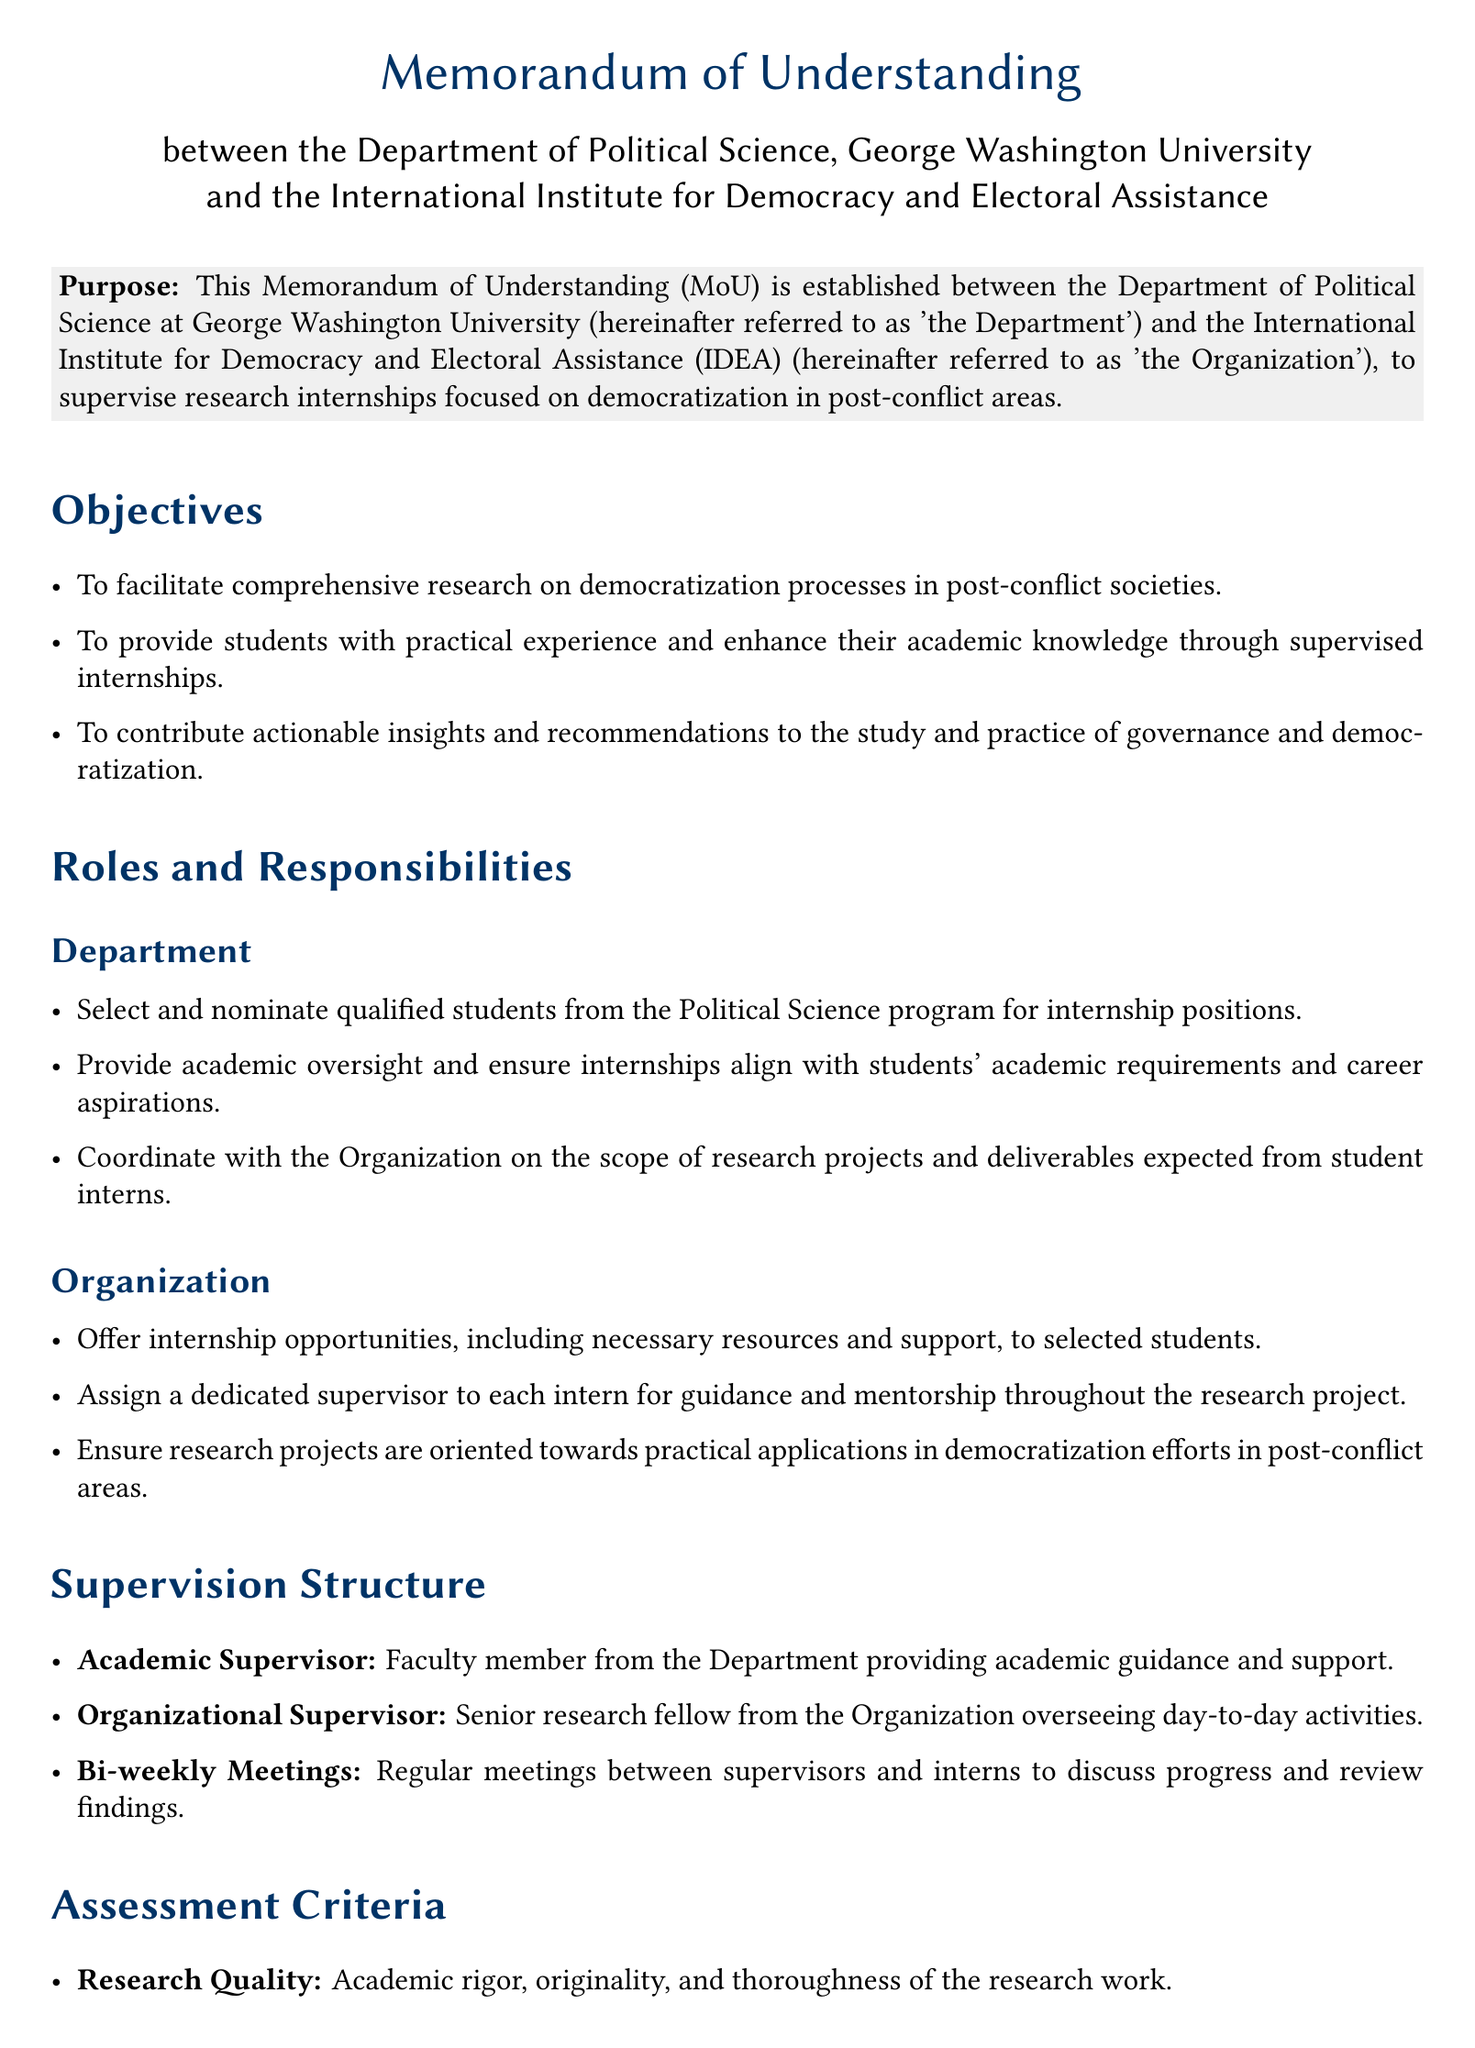What are the names of the two parties involved? The document identifies the two parties as the Department of Political Science at George Washington University and the International Institute for Democracy and Electoral Assistance.
Answer: Department of Political Science, International Institute for Democracy and Electoral Assistance Who is the representative from the Department? The representative from the Department is mentioned in the signature section of the document as Dr. Jane Doe.
Answer: Dr. Jane Doe What is the primary purpose of the Memorandum of Understanding? The primary purpose is outlined in the document and focuses on supervising research internships in democratization in post-conflict areas.
Answer: Supervise research internships focused on democratization in post-conflict areas How often do the supervisors and interns meet? The document specifies that there are regular meetings between supervisors and interns to discuss progress.
Answer: Bi-weekly What is one assessment criterion mentioned in the document? The document lists various criteria including research quality and practical impact, indicating the importance of the rigor and contributions of research work.
Answer: Research Quality Who is the representative from the Organization? The representative from the Organization is specified in the document as Mr. John Smith.
Answer: Mr. John Smith What role does the Academic Supervisor play? The document states that the Academic Supervisor is a faculty member who provides academic guidance and support to the interns.
Answer: Academic guidance and support In what type of areas do the research projects need to focus? The document specifies that the research projects should be oriented towards practical applications in democratization efforts.
Answer: Democratization in post-conflict areas 